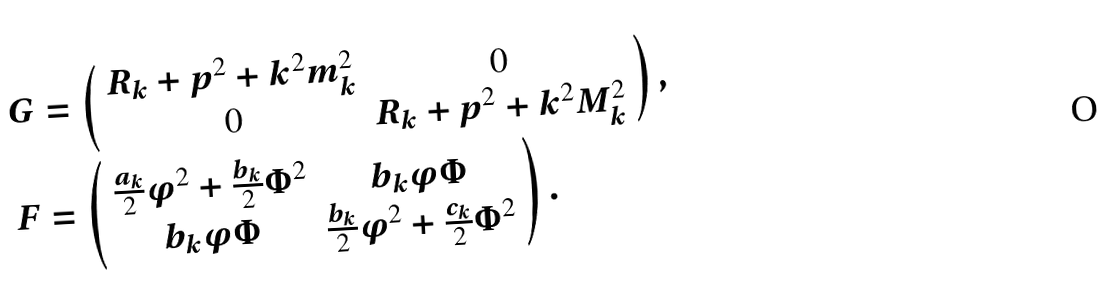<formula> <loc_0><loc_0><loc_500><loc_500>G & = \left ( \begin{array} { c c } R _ { k } + p ^ { 2 } + k ^ { 2 } m _ { k } ^ { 2 } & 0 \\ 0 & R _ { k } + p ^ { 2 } + k ^ { 2 } M _ { k } ^ { 2 } \end{array} \right ) , \\ F & = \left ( \begin{array} { c c } \frac { a _ { k } } 2 \varphi ^ { 2 } + \frac { b _ { k } } { 2 } \Phi ^ { 2 } & b _ { k } \varphi \Phi \\ b _ { k } \varphi \Phi & \frac { b _ { k } } { 2 } \varphi ^ { 2 } + \frac { c _ { k } } 2 \Phi ^ { 2 } \end{array} \right ) .</formula> 